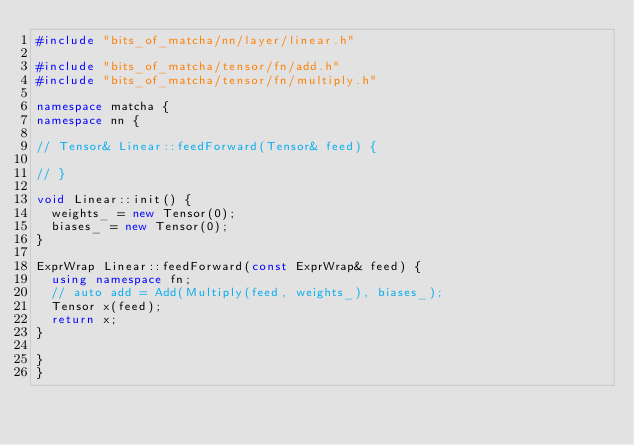Convert code to text. <code><loc_0><loc_0><loc_500><loc_500><_C++_>#include "bits_of_matcha/nn/layer/linear.h"

#include "bits_of_matcha/tensor/fn/add.h"
#include "bits_of_matcha/tensor/fn/multiply.h"

namespace matcha {
namespace nn {

// Tensor& Linear::feedForward(Tensor& feed) {

// }

void Linear::init() {
  weights_ = new Tensor(0);
  biases_ = new Tensor(0);
}

ExprWrap Linear::feedForward(const ExprWrap& feed) {
  using namespace fn;
  // auto add = Add(Multiply(feed, weights_), biases_);
  Tensor x(feed);
  return x;
}

}
}</code> 